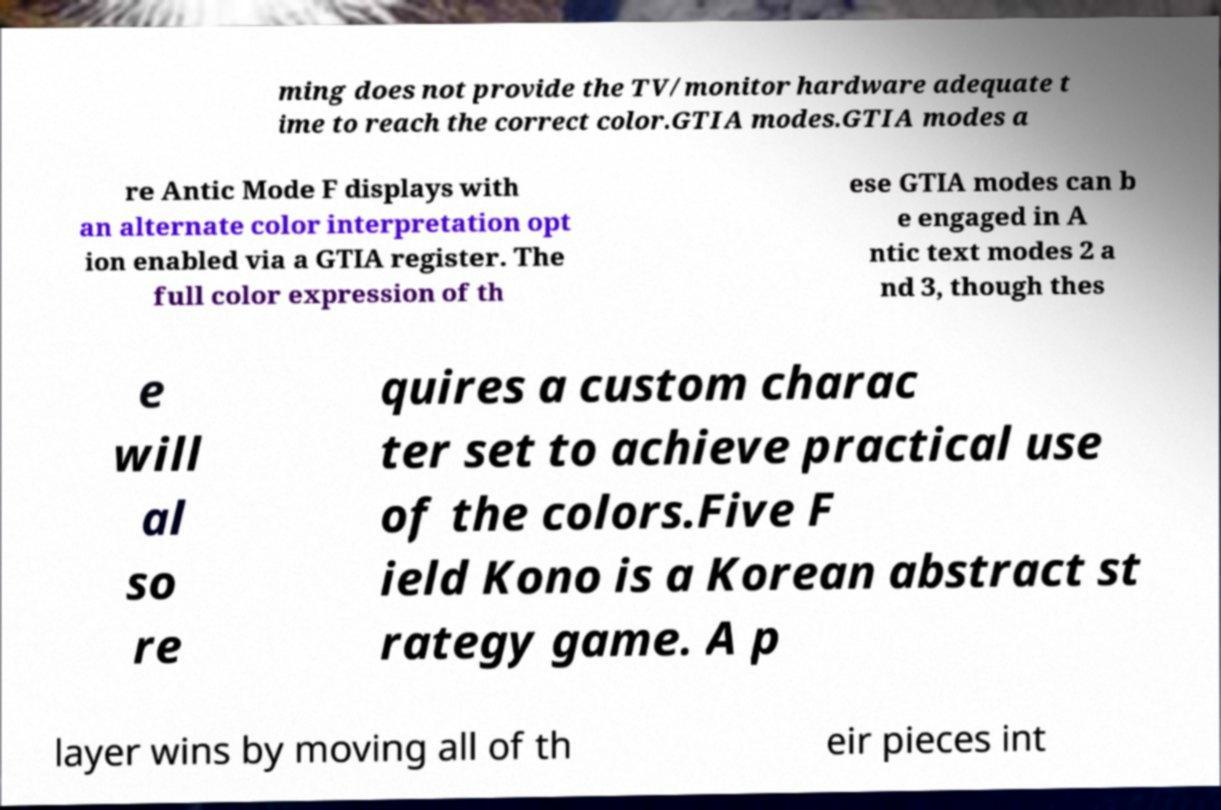Could you extract and type out the text from this image? ming does not provide the TV/monitor hardware adequate t ime to reach the correct color.GTIA modes.GTIA modes a re Antic Mode F displays with an alternate color interpretation opt ion enabled via a GTIA register. The full color expression of th ese GTIA modes can b e engaged in A ntic text modes 2 a nd 3, though thes e will al so re quires a custom charac ter set to achieve practical use of the colors.Five F ield Kono is a Korean abstract st rategy game. A p layer wins by moving all of th eir pieces int 